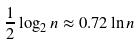Convert formula to latex. <formula><loc_0><loc_0><loc_500><loc_500>\frac { 1 } { 2 } \log _ { 2 } n \approx 0 . 7 2 \ln n</formula> 